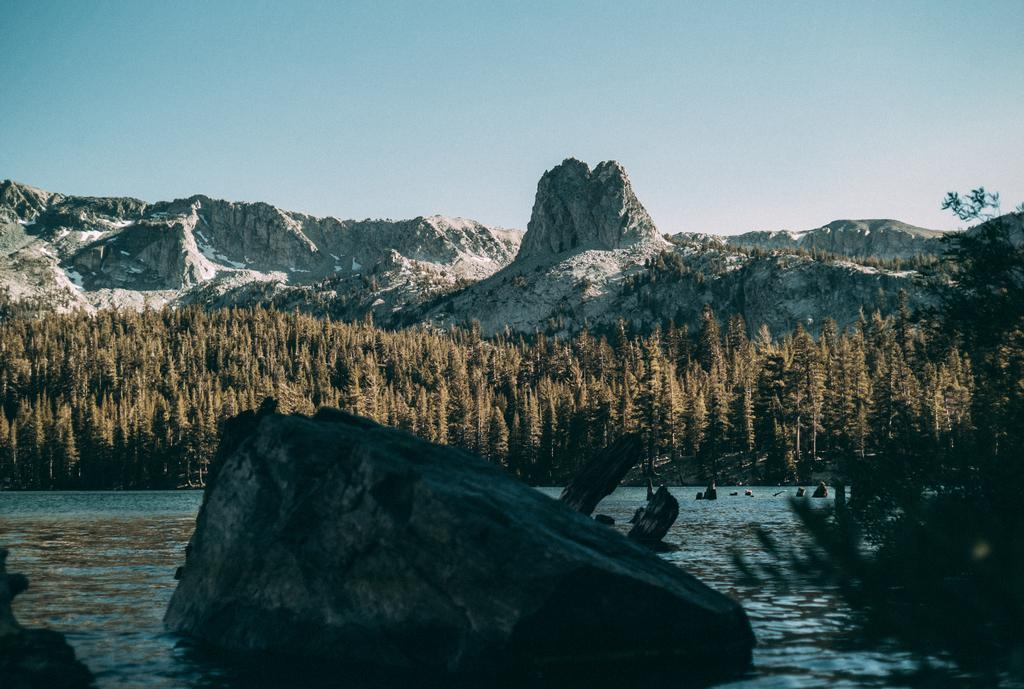What can be seen in the image that is not solid? There is water visible in the image. What type of vegetation is present in the image? There are trees in the image. What type of landscape feature can be seen in the image? There are hills in the image. What type of pin is being used to polish the writing in the image? There is no pin, polish, or writing present in the image. 